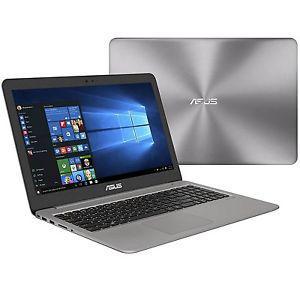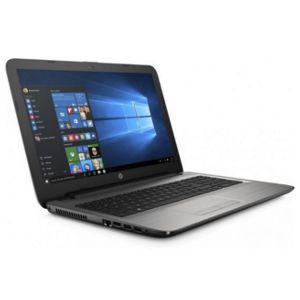The first image is the image on the left, the second image is the image on the right. Analyze the images presented: Is the assertion "The left image features an open, rightward facing laptop overlapping an upright closed silver laptop, and the right image contains only an open, rightward facing laptop." valid? Answer yes or no. Yes. The first image is the image on the left, the second image is the image on the right. Assess this claim about the two images: "One image contains only one laptop and the other image contains one open laptop and one closed laptop.". Correct or not? Answer yes or no. Yes. 